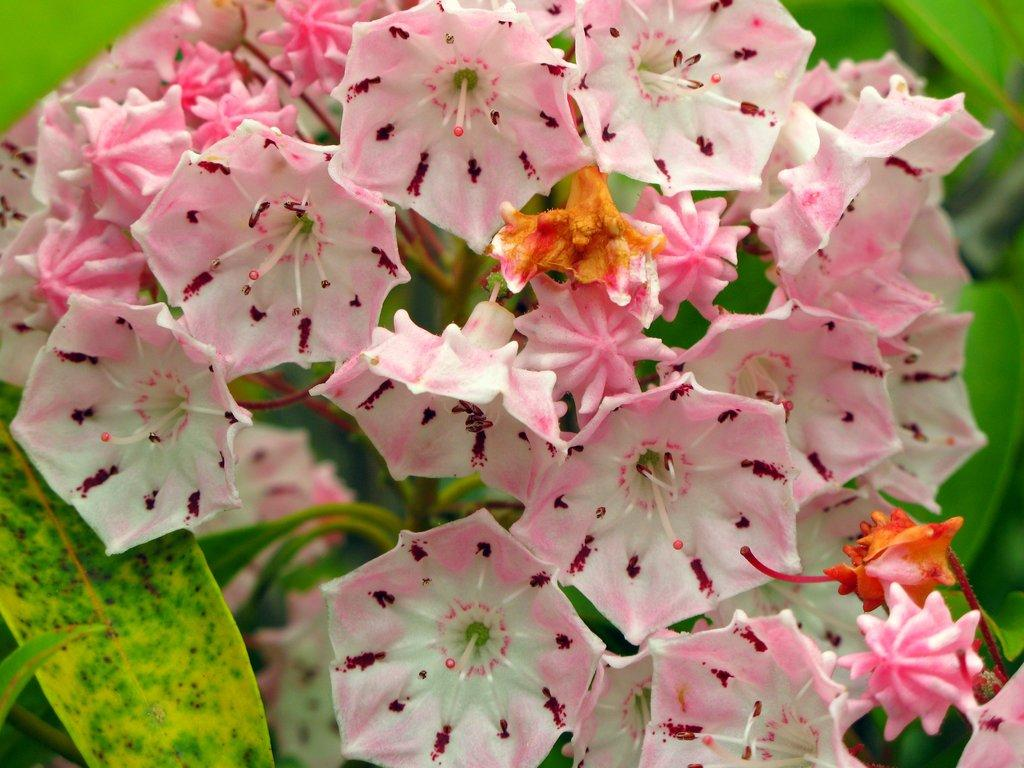What type of living organisms can be seen in the image? There are flowers in the image. What colors are the flowers in the image? The flowers are pink, cream, yellow, and red in color. What colors are present on the plant that the flowers are growing on? The plant has green and yellow colors. Can you tell me how many people are holding the flowers in the image? There are no people present in the image; it only features flowers and a plant. Are there any flies buzzing around the flowers in the image? There is no mention of flies in the image, so we cannot determine their presence. 